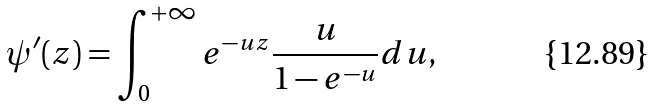<formula> <loc_0><loc_0><loc_500><loc_500>\psi ^ { \prime } ( z ) = \int _ { 0 } ^ { + \infty } e ^ { - u z } \frac { u } { 1 - e ^ { - u } } d u ,</formula> 